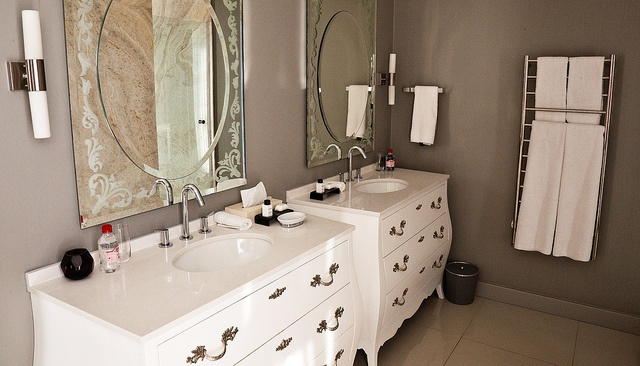Describe the objects in this image and their specific colors. I can see sink in darkgray, lightgray, and tan tones, vase in darkgray, black, and gray tones, sink in darkgray, tan, and gray tones, and bowl in darkgray and lightgray tones in this image. 